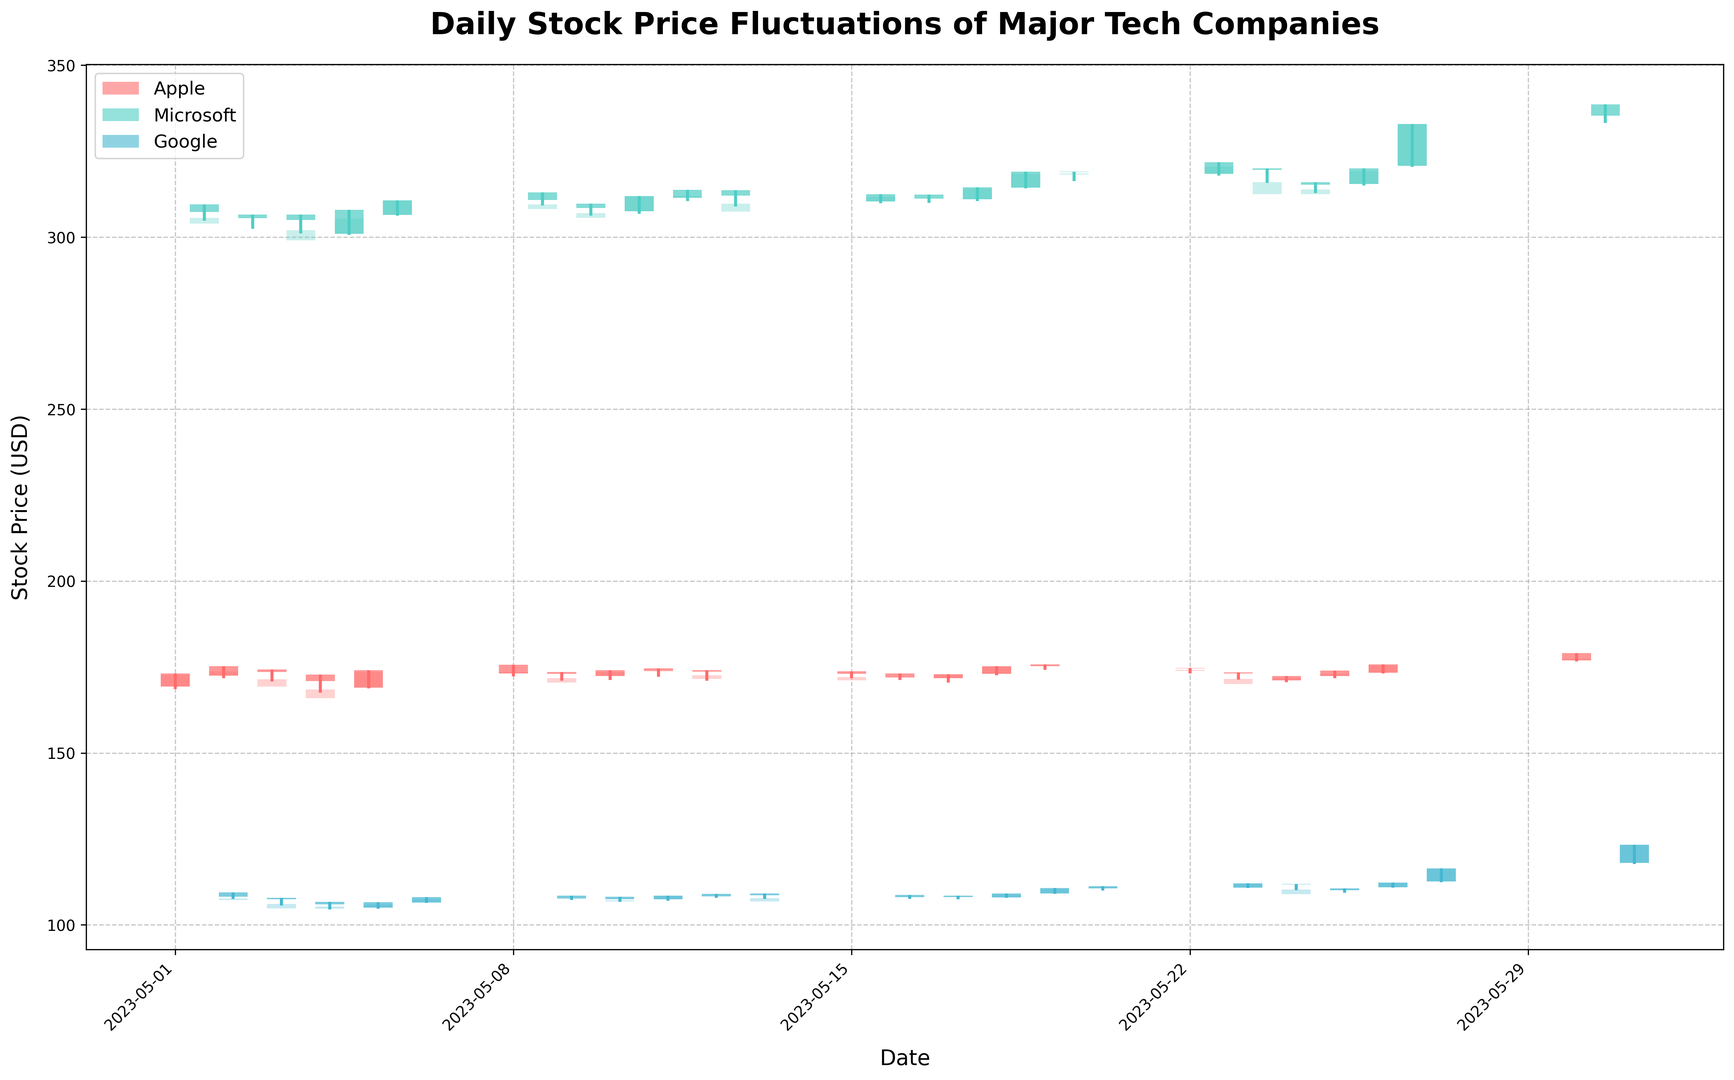What is the highest closing price for Apple during the month? Identify the highest closing price among the daily values for Apple. This requires scanning the plot for the highest point reached by the closing prices of Apple's stock.
Answer: 177.30 Which company's stock showed the most significant price increase on a single day and what was the amount of the increase? To find this, look for the day-to-day price range for each company, identifying the largest difference between the open and close prices within a single day.
Answer: Google, 5.61 On which date did Google experience the highest volume of trading, as inferred from the longest bar length in the plot? Look for the tallest bar within Google's data showing the largest gap between high and low prices, which likely indicates higher trading activity.
Answer: 2023-05-30 Did any of the companies have a day where their stock price closed at exactly 310.00? Check each company's closing prices against the value 310.00 to see if there is a match on any given day.
Answer: No What was the average closing price for Microsoft during the first week of May? Calculate the arithmetic mean of Microsoft's closing prices from May 1 to May 5 inclusive. The closing prices are 305.56, 305.41, 302.00, 305.41, and 310.65. Summing these gives 1529.03, which when divided by 5 is 305.806.
Answer: 305.81 Compare the highest stock prices reached by Apple and Microsoft during the month. Which stock had a higher peak? Identify the highest price reached by each stock in the month by looking at the peak values for both Apple and Microsoft.
Answer: Microsoft, 338.56 What is the range of Google's stock prices on May 26th, and how does it compare to Microsoft's range on the same day? Calculate the range (High - Low) for Google and Microsoft on May 26th and then compare these values. For Google, the range is (116.47 - 112.39) = 4.08, and for Microsoft, it’s (332.89 - 320.37) = 12.52.
Answer: Google: 4.08, Microsoft: 12.52 What date did Microsoft’s stock last close at its highest price for the month? Scan the plot for the day with the highest closing price for Microsoft's stock, noting the corresponding date.
Answer: 2023-05-30 On which date did Apple experience the most minor fluctuation in stock price? Identify the date with the smallest range between the high and low prices for Apple's stock.
Answer: 2023-05-22 Which company showed the most consistent daily closing prices throughout the month? Consistency can be estimated by observing the tightness of the daily closing prices for each company's bars. Google shows clustered close values with very small daily variations.
Answer: Google 